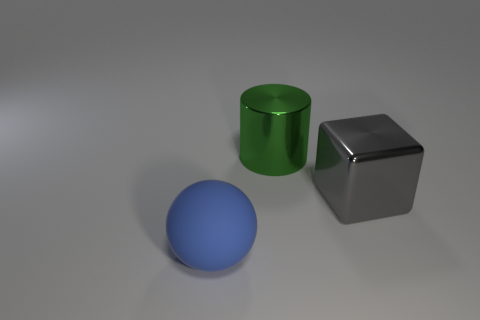Add 2 gray cylinders. How many objects exist? 5 Subtract all blocks. How many objects are left? 2 Subtract 0 green balls. How many objects are left? 3 Subtract all large gray blocks. Subtract all gray metal blocks. How many objects are left? 1 Add 2 big matte spheres. How many big matte spheres are left? 3 Add 2 large matte spheres. How many large matte spheres exist? 3 